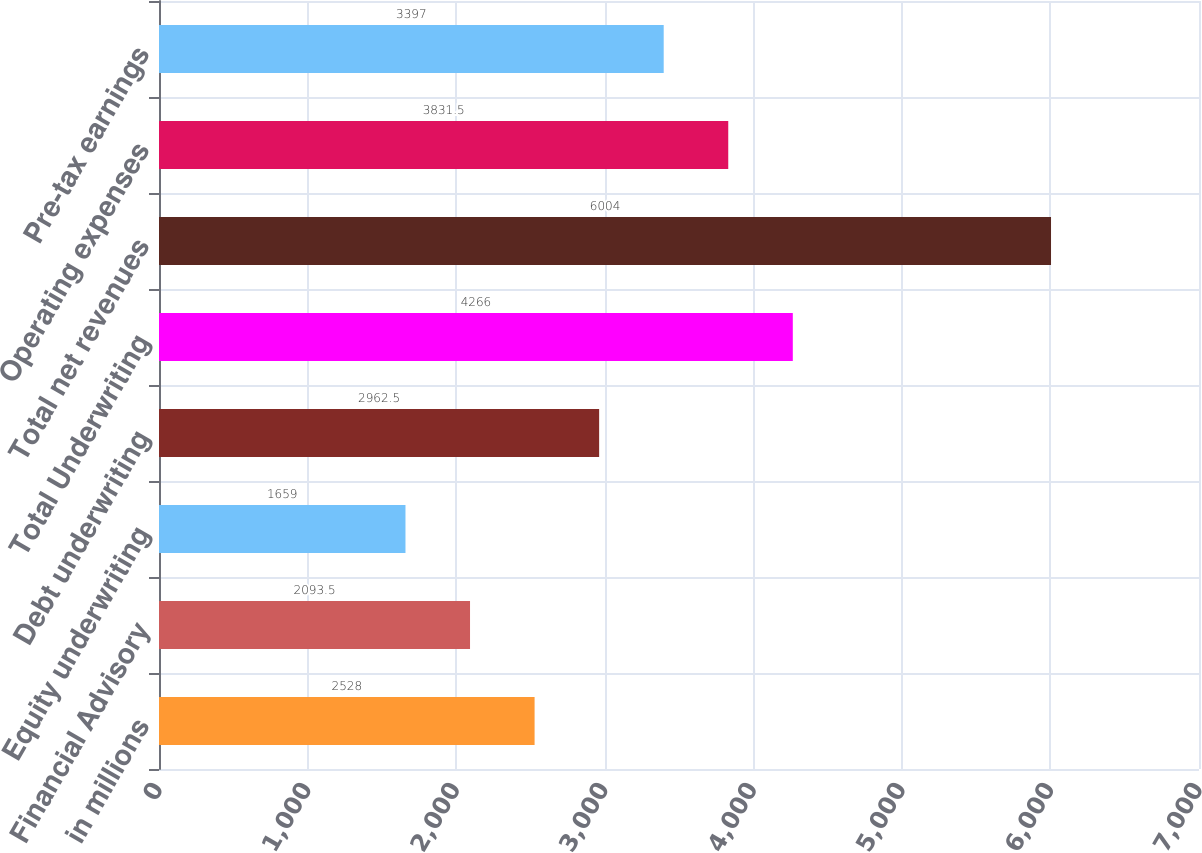Convert chart. <chart><loc_0><loc_0><loc_500><loc_500><bar_chart><fcel>in millions<fcel>Financial Advisory<fcel>Equity underwriting<fcel>Debt underwriting<fcel>Total Underwriting<fcel>Total net revenues<fcel>Operating expenses<fcel>Pre-tax earnings<nl><fcel>2528<fcel>2093.5<fcel>1659<fcel>2962.5<fcel>4266<fcel>6004<fcel>3831.5<fcel>3397<nl></chart> 